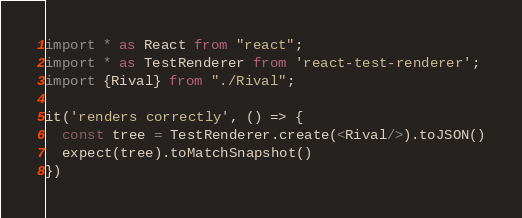<code> <loc_0><loc_0><loc_500><loc_500><_TypeScript_>import * as React from "react";
import * as TestRenderer from 'react-test-renderer';
import {Rival} from "./Rival";

it('renders correctly', () => {
  const tree = TestRenderer.create(<Rival/>).toJSON()
  expect(tree).toMatchSnapshot()
})
</code> 